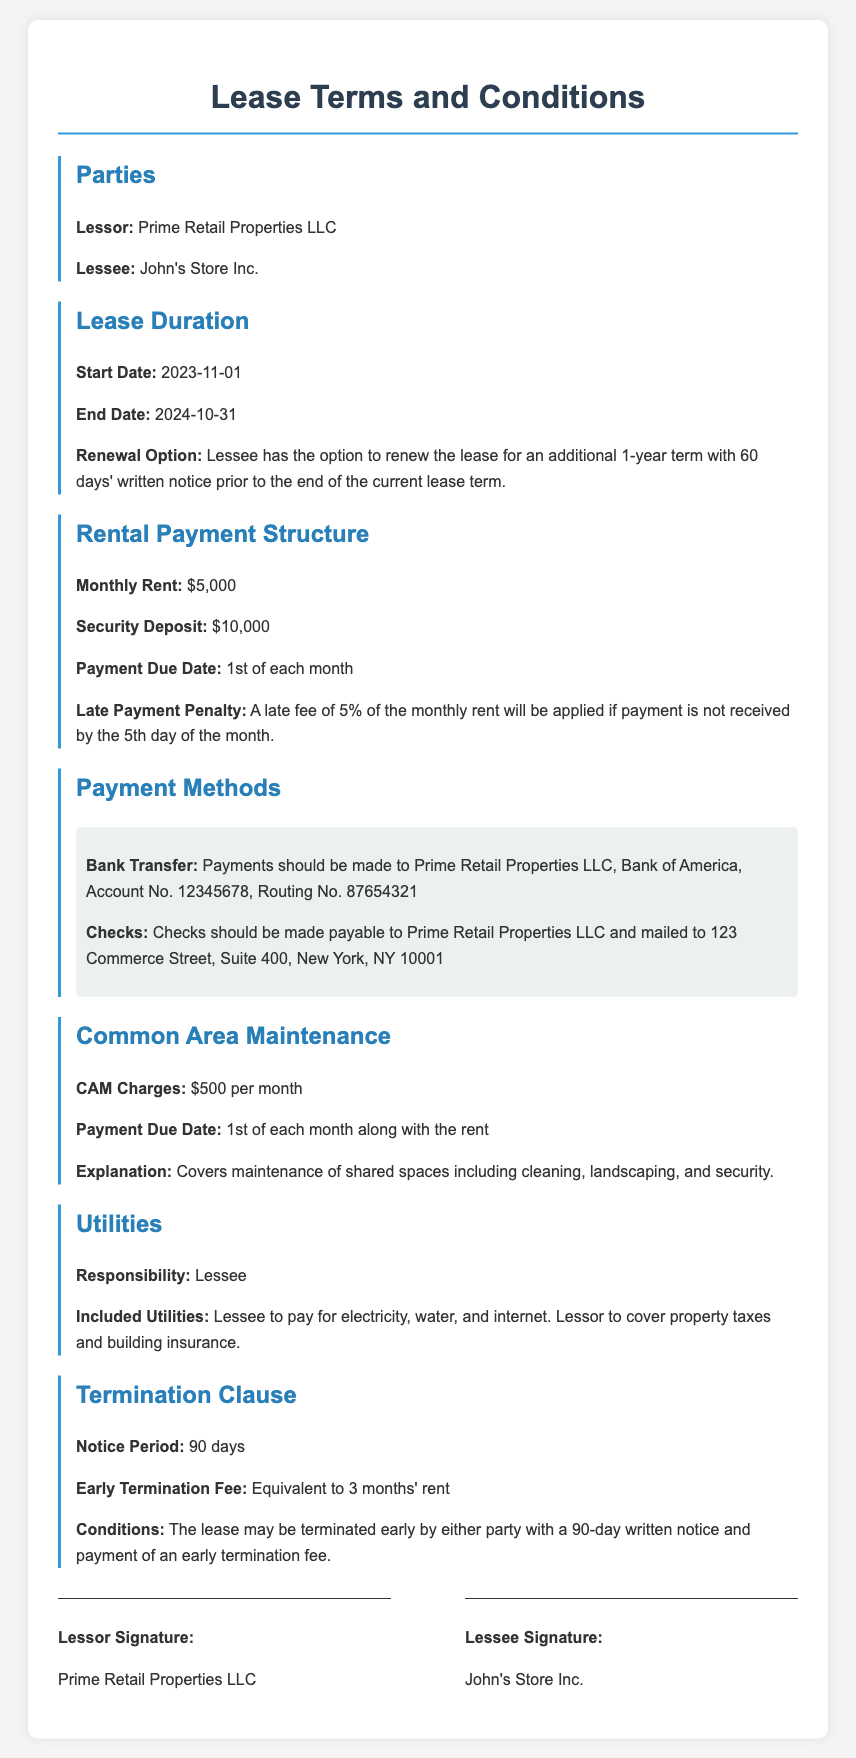What is the name of the Lessor? The name of the Lessor is listed in the document under the Parties section as Prime Retail Properties LLC.
Answer: Prime Retail Properties LLC What is the duration of the lease? The lease duration is defined in the Lease Duration section, with a Start Date of 2023-11-01 and an End Date of 2024-10-31.
Answer: 1 year What is the monthly rent amount? The monthly rent is specified under the Rental Payment Structure section as $5,000.
Answer: $5,000 When is the rental payment due? The due date for rental payments is mentioned in the Rental Payment Structure section as the 1st of each month.
Answer: 1st of each month What is the late payment penalty? The late payment penalty is discussed in the Rental Payment Structure section, which states that a late fee of 5% of the monthly rent will be applied if payment is not received by the 5th day of the month.
Answer: 5% How much is the security deposit? The document states the security deposit amount in the Rental Payment Structure section, which is $10,000.
Answer: $10,000 What is the Common Area Maintenance charge? Common Area Maintenance charges are detailed in the Common Area Maintenance section, which states that the charge is $500 per month.
Answer: $500 How many days notice is required for lease termination? The Notice Period for lease termination is stated in the Termination Clause section as 90 days.
Answer: 90 days What is the early termination fee? The early termination fee is mentioned in the Termination Clause section, stating it is equivalent to 3 months' rent.
Answer: 3 months' rent 